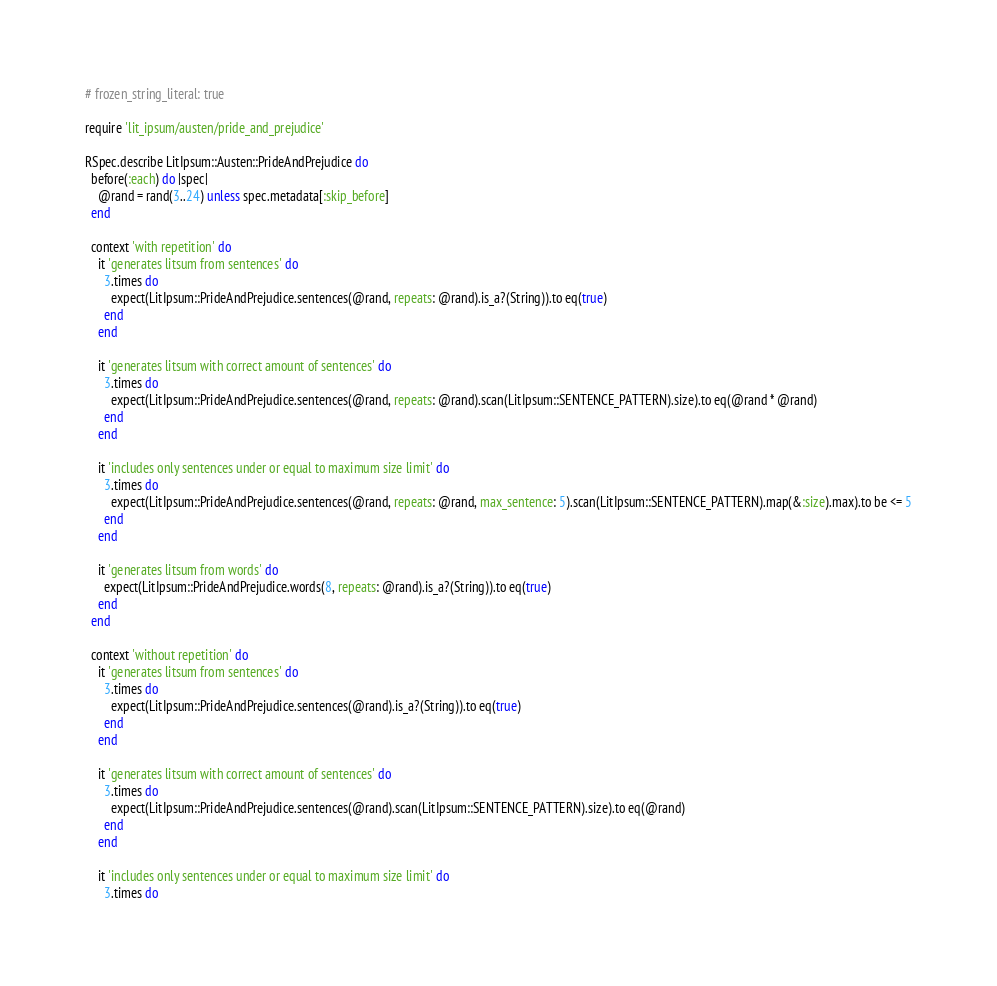Convert code to text. <code><loc_0><loc_0><loc_500><loc_500><_Ruby_># frozen_string_literal: true

require 'lit_ipsum/austen/pride_and_prejudice'

RSpec.describe LitIpsum::Austen::PrideAndPrejudice do
  before(:each) do |spec|
    @rand = rand(3..24) unless spec.metadata[:skip_before]
  end

  context 'with repetition' do
    it 'generates litsum from sentences' do
      3.times do
        expect(LitIpsum::PrideAndPrejudice.sentences(@rand, repeats: @rand).is_a?(String)).to eq(true)
      end
    end

    it 'generates litsum with correct amount of sentences' do
      3.times do
        expect(LitIpsum::PrideAndPrejudice.sentences(@rand, repeats: @rand).scan(LitIpsum::SENTENCE_PATTERN).size).to eq(@rand * @rand)
      end
    end

    it 'includes only sentences under or equal to maximum size limit' do
      3.times do
        expect(LitIpsum::PrideAndPrejudice.sentences(@rand, repeats: @rand, max_sentence: 5).scan(LitIpsum::SENTENCE_PATTERN).map(&:size).max).to be <= 5
      end
    end

    it 'generates litsum from words' do
      expect(LitIpsum::PrideAndPrejudice.words(8, repeats: @rand).is_a?(String)).to eq(true)
    end
  end

  context 'without repetition' do
    it 'generates litsum from sentences' do
      3.times do
        expect(LitIpsum::PrideAndPrejudice.sentences(@rand).is_a?(String)).to eq(true)
      end
    end

    it 'generates litsum with correct amount of sentences' do
      3.times do
        expect(LitIpsum::PrideAndPrejudice.sentences(@rand).scan(LitIpsum::SENTENCE_PATTERN).size).to eq(@rand)
      end
    end

    it 'includes only sentences under or equal to maximum size limit' do
      3.times do</code> 